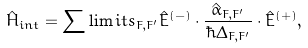<formula> <loc_0><loc_0><loc_500><loc_500>\hat { H } _ { i n t } = \sum \lim i t s _ { F , F ^ { \prime } } { { \hat { E } } ^ { ( - ) } \cdot \frac { { \hat { \alpha } _ { F , F ^ { \prime } } } } { { \hbar { \Delta } _ { F , F ^ { \prime } } } } \cdot { \hat { E } } ^ { ( + ) } } ,</formula> 